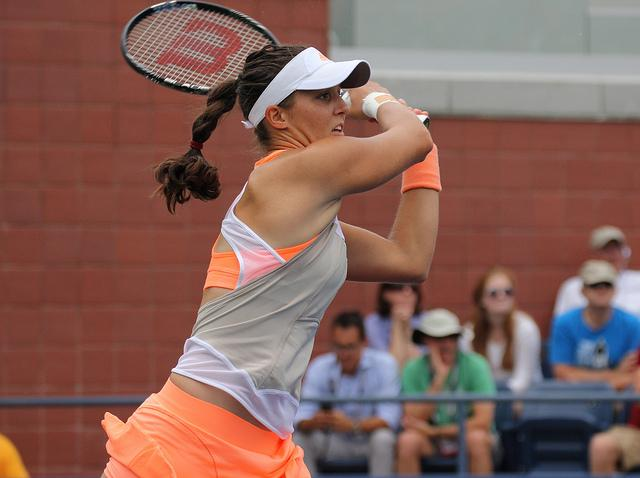What brand of tennis racket is she using to play? Please explain your reasoning. head. The tennis racket has the logo for wilson on it. 